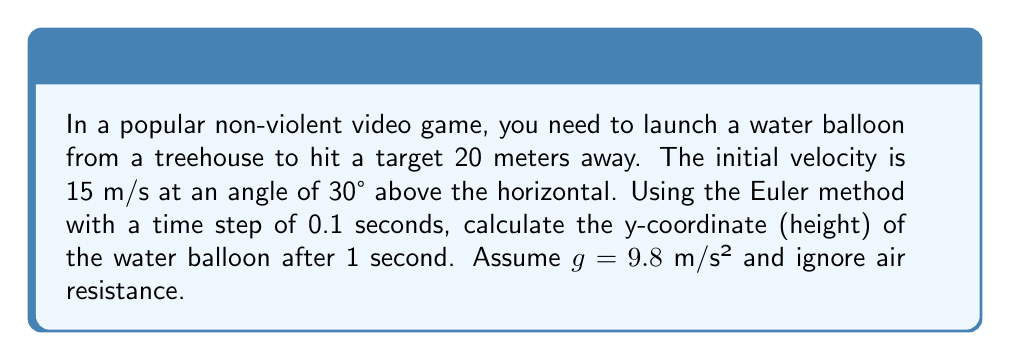Help me with this question. Let's solve this step-by-step using the Euler method:

1) First, we need to break down the initial velocity into x and y components:
   $v_x = 15 \cos(30°) = 12.99 \text{ m/s}$
   $v_y = 15 \sin(30°) = 7.5 \text{ m/s}$

2) The Euler method for this problem can be expressed as:
   $$x_{n+1} = x_n + v_x \Delta t$$
   $$y_{n+1} = y_n + v_y \Delta t$$
   $$v_{y,n+1} = v_{y,n} - g \Delta t$$

3) We'll use a time step $\Delta t = 0.1 \text{ s}$ and calculate for 10 steps to reach 1 second.

4) Initial conditions:
   $t_0 = 0 \text{ s}, x_0 = 0 \text{ m}, y_0 = 0 \text{ m}, v_{y,0} = 7.5 \text{ m/s}$

5) Let's calculate the first few steps:

   Step 1 (t = 0.1 s):
   $x_1 = 0 + 12.99 * 0.1 = 1.299 \text{ m}$
   $y_1 = 0 + 7.5 * 0.1 = 0.75 \text{ m}$
   $v_{y,1} = 7.5 - 9.8 * 0.1 = 6.52 \text{ m/s}$

   Step 2 (t = 0.2 s):
   $x_2 = 1.299 + 12.99 * 0.1 = 2.598 \text{ m}$
   $y_2 = 0.75 + 6.52 * 0.1 = 1.402 \text{ m}$
   $v_{y,2} = 6.52 - 9.8 * 0.1 = 5.54 \text{ m/s}$

6) Continuing this process for 10 steps (1 second), we get:
   $y_{10} = 4.289 \text{ m}$

Therefore, after 1 second, the water balloon will be approximately 4.289 meters high.
Answer: 4.289 m 